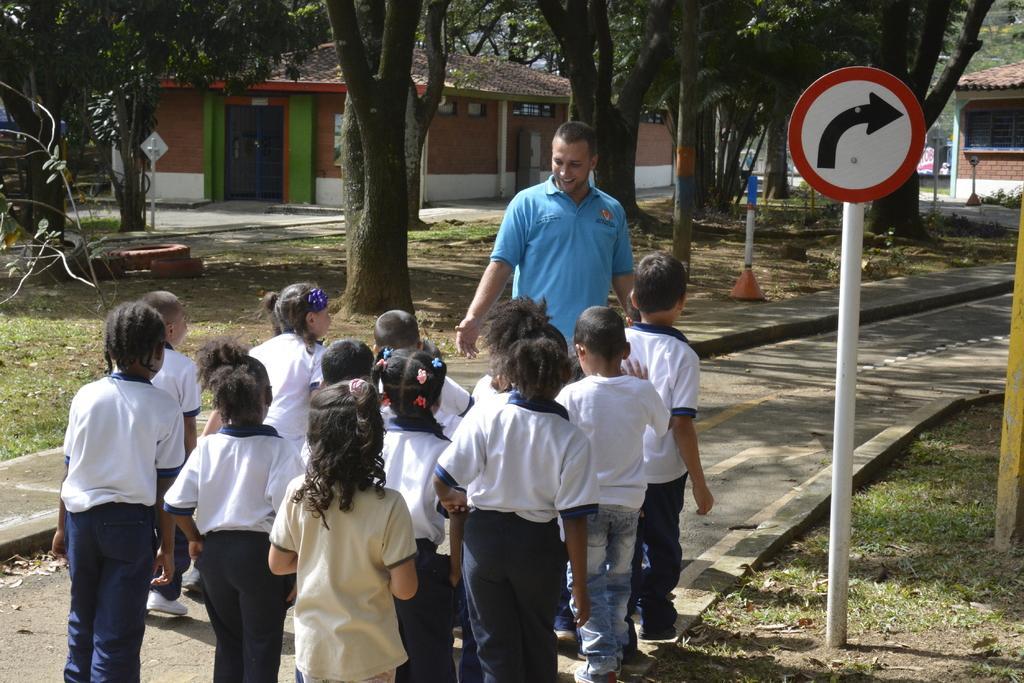Can you describe this image briefly? In the image there is a man and in front of the man there are few children, around them there are trees, grass, houses and on the right side there is a directional board. 